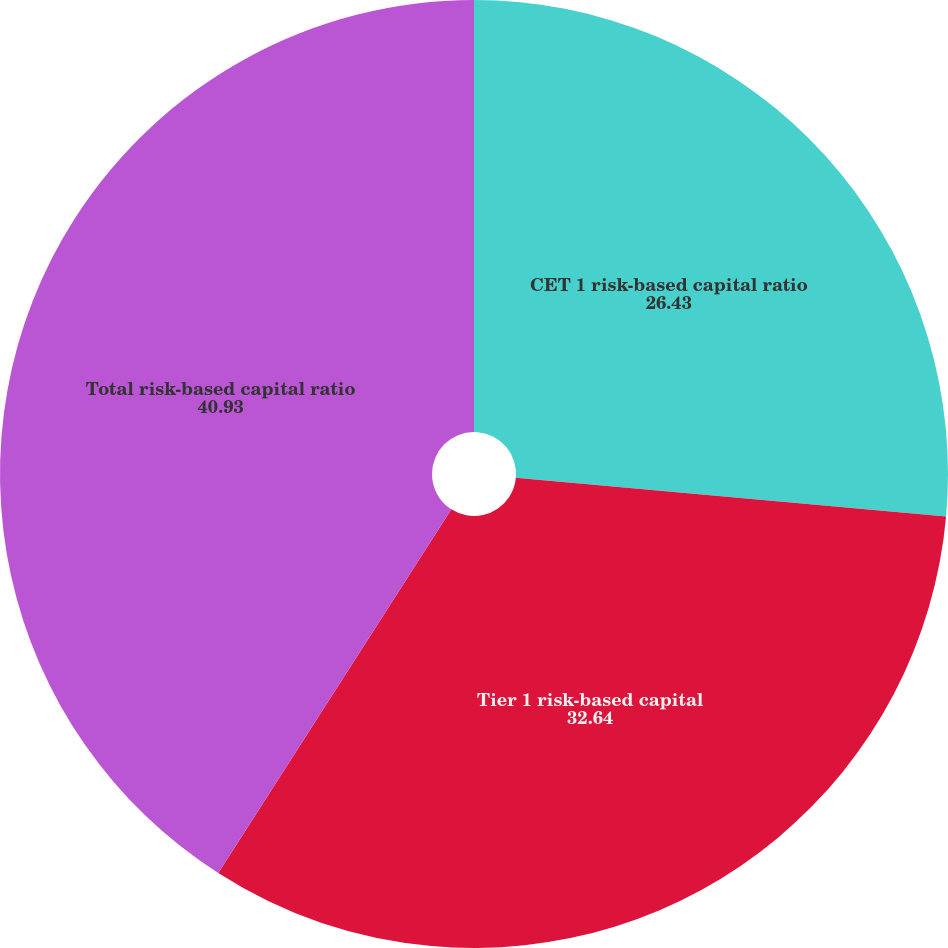<chart> <loc_0><loc_0><loc_500><loc_500><pie_chart><fcel>CET 1 risk-based capital ratio<fcel>Tier 1 risk-based capital<fcel>Total risk-based capital ratio<nl><fcel>26.43%<fcel>32.64%<fcel>40.93%<nl></chart> 